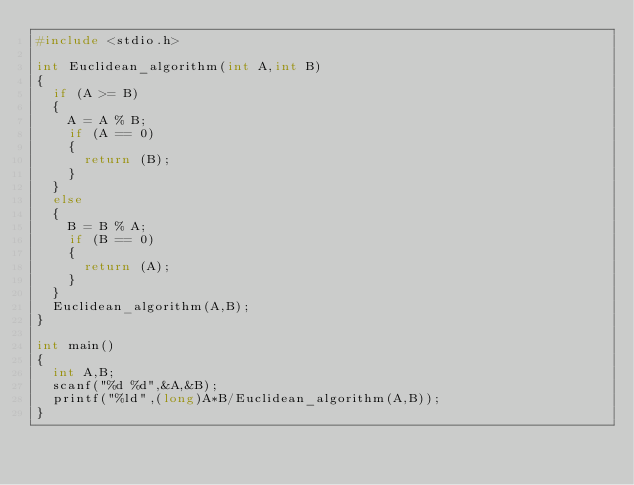<code> <loc_0><loc_0><loc_500><loc_500><_C_>#include <stdio.h>

int Euclidean_algorithm(int A,int B)
{
  if (A >= B)
  {
    A = A % B;
    if (A == 0)
    {
      return (B);
    }
  }
  else
  {
    B = B % A;
    if (B == 0)
    {
      return (A);
    }
  }
  Euclidean_algorithm(A,B);
}

int main()
{
  int A,B;
  scanf("%d %d",&A,&B);
  printf("%ld",(long)A*B/Euclidean_algorithm(A,B));
}</code> 